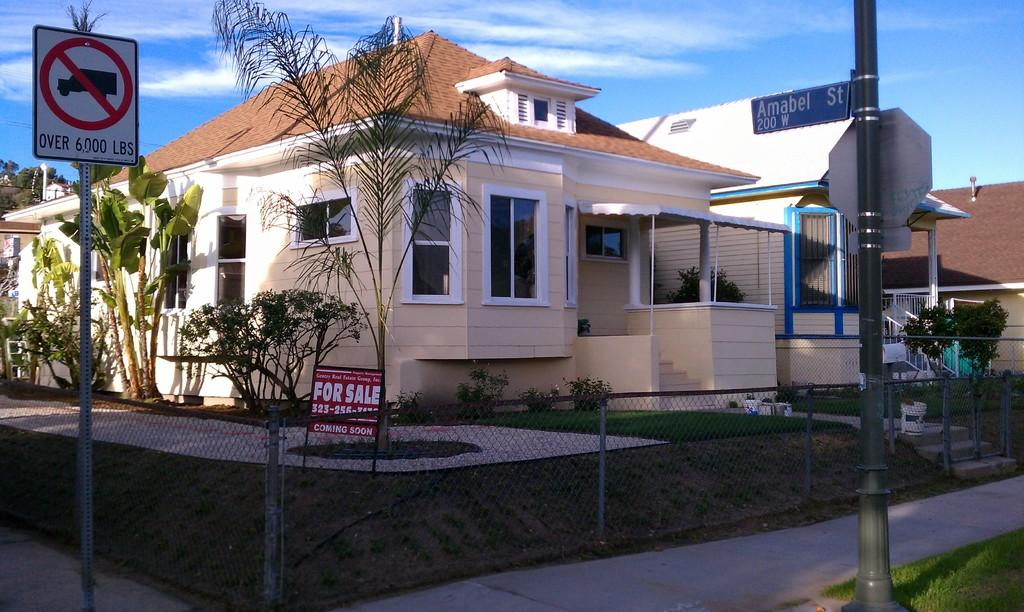<image>
Relay a brief, clear account of the picture shown. A House is for sale on the corner of the street. 